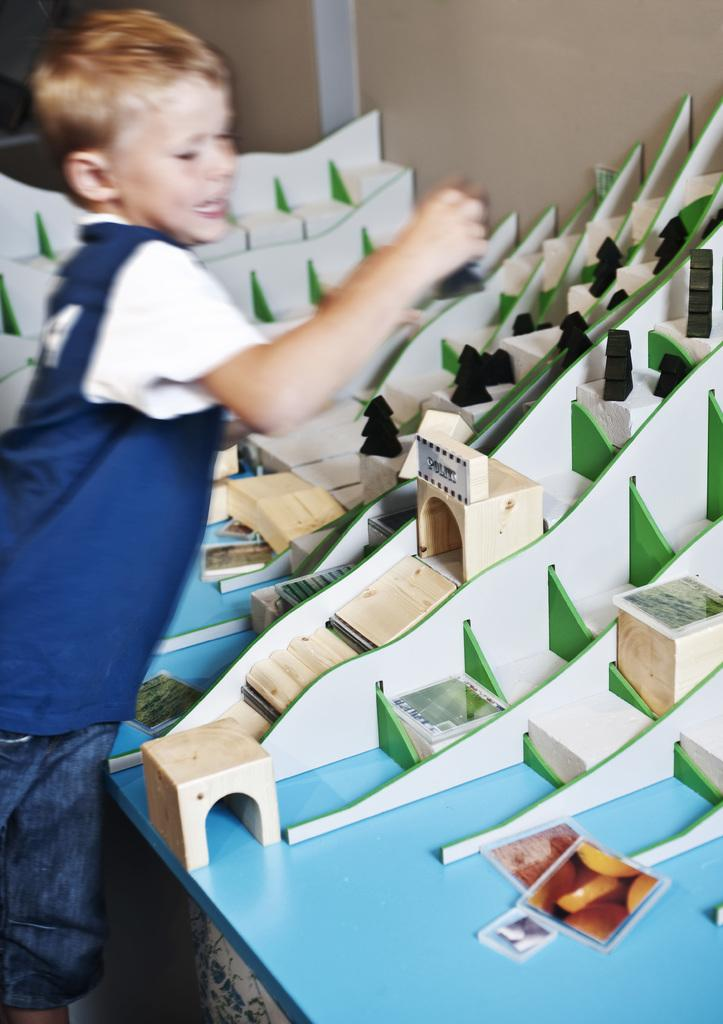What is the main subject of the image? The main subject of the image is a kid. Where is the kid positioned in relation to the table? The kid is standing in front of a table. What can be seen on the table in the image? There are things placed on the table. What date is circled on the calendar in the image? There is no calendar present in the image. What type of neck accessory is the kid wearing in the image? There is no neck accessory mentioned in the facts provided for the image. 